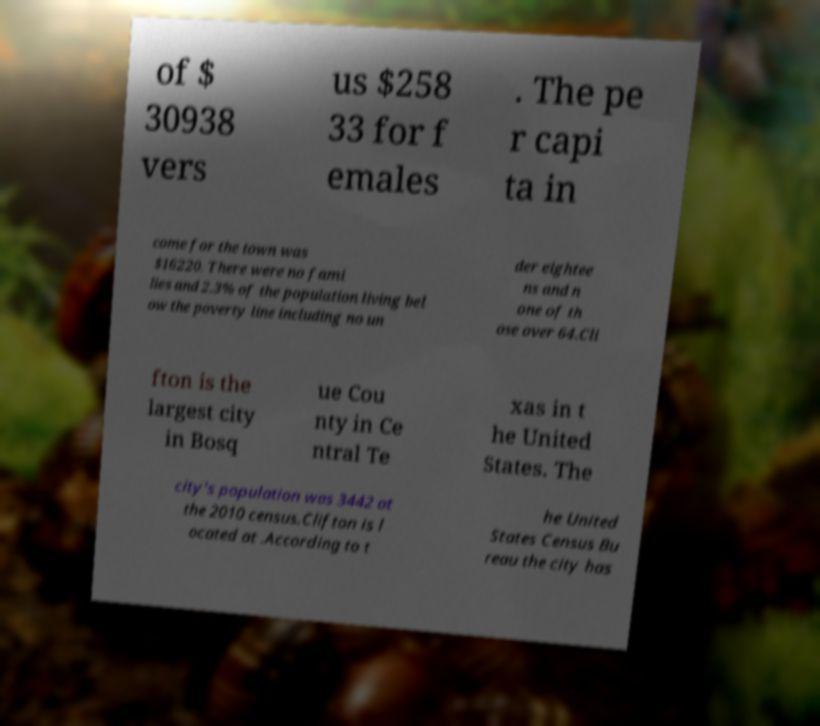There's text embedded in this image that I need extracted. Can you transcribe it verbatim? of $ 30938 vers us $258 33 for f emales . The pe r capi ta in come for the town was $16220. There were no fami lies and 2.3% of the population living bel ow the poverty line including no un der eightee ns and n one of th ose over 64.Cli fton is the largest city in Bosq ue Cou nty in Ce ntral Te xas in t he United States. The city's population was 3442 at the 2010 census.Clifton is l ocated at .According to t he United States Census Bu reau the city has 